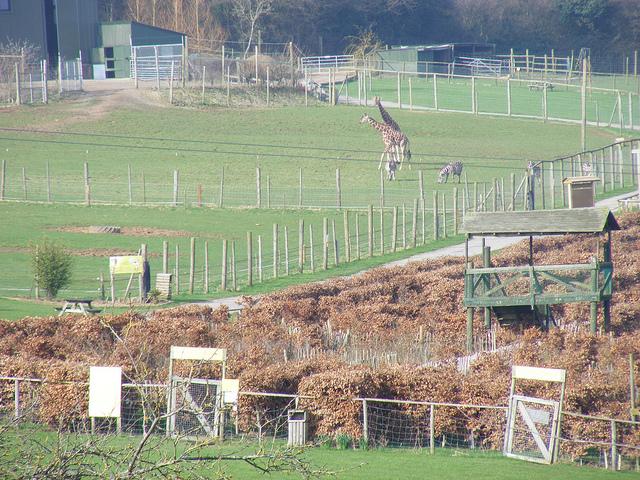What are the fence posts made of?
Concise answer only. Wood. Name an animal that resides at this sanctuary:?
Concise answer only. Giraffe. Is there a trash can shown?
Short answer required. Yes. 